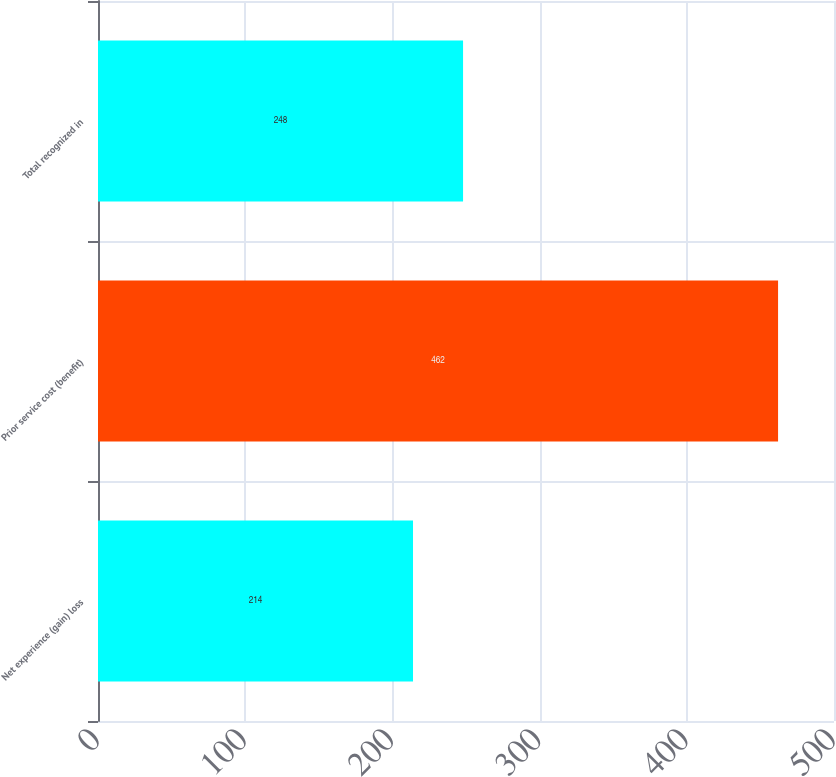Convert chart. <chart><loc_0><loc_0><loc_500><loc_500><bar_chart><fcel>Net experience (gain) loss<fcel>Prior service cost (benefit)<fcel>Total recognized in<nl><fcel>214<fcel>462<fcel>248<nl></chart> 